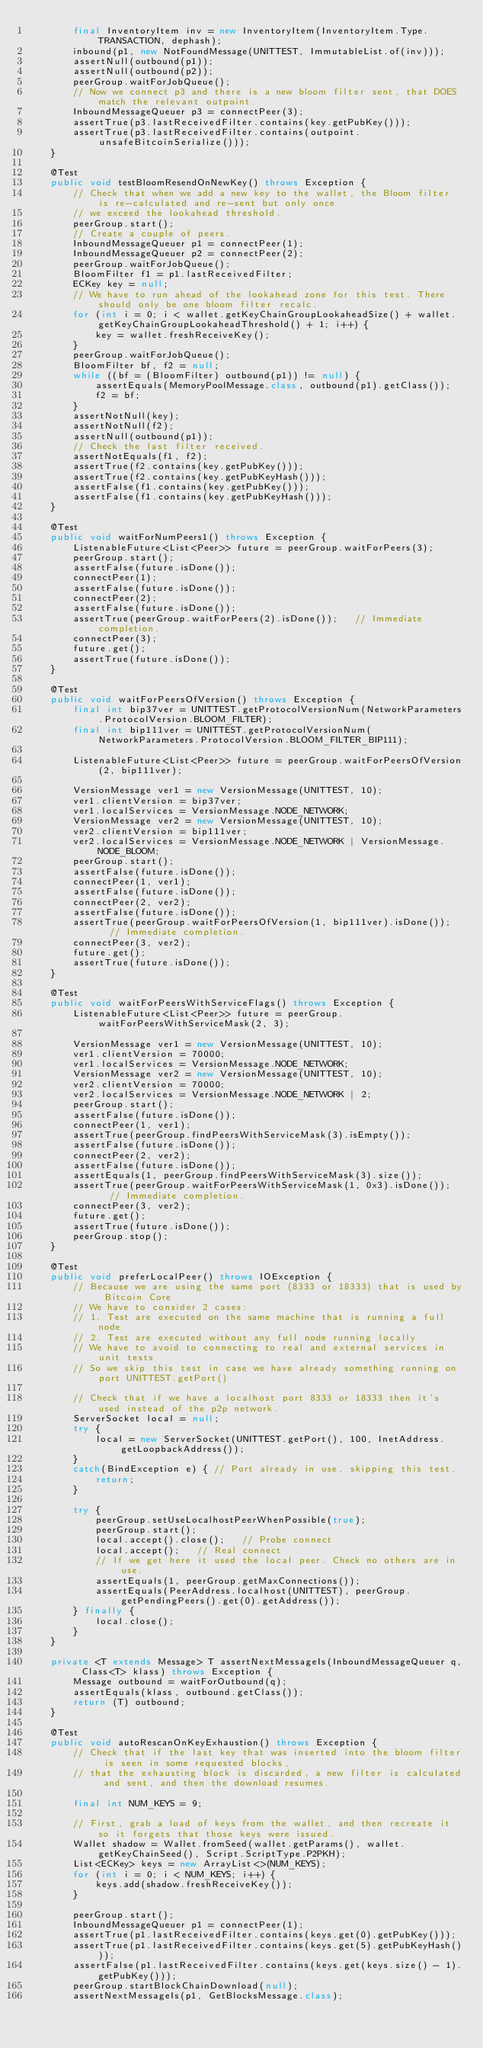Convert code to text. <code><loc_0><loc_0><loc_500><loc_500><_Java_>        final InventoryItem inv = new InventoryItem(InventoryItem.Type.TRANSACTION, dephash);
        inbound(p1, new NotFoundMessage(UNITTEST, ImmutableList.of(inv)));
        assertNull(outbound(p1));
        assertNull(outbound(p2));
        peerGroup.waitForJobQueue();
        // Now we connect p3 and there is a new bloom filter sent, that DOES match the relevant outpoint.
        InboundMessageQueuer p3 = connectPeer(3);
        assertTrue(p3.lastReceivedFilter.contains(key.getPubKey()));
        assertTrue(p3.lastReceivedFilter.contains(outpoint.unsafeBitcoinSerialize()));
    }

    @Test
    public void testBloomResendOnNewKey() throws Exception {
        // Check that when we add a new key to the wallet, the Bloom filter is re-calculated and re-sent but only once
        // we exceed the lookahead threshold.
        peerGroup.start();
        // Create a couple of peers.
        InboundMessageQueuer p1 = connectPeer(1);
        InboundMessageQueuer p2 = connectPeer(2);
        peerGroup.waitForJobQueue();
        BloomFilter f1 = p1.lastReceivedFilter;
        ECKey key = null;
        // We have to run ahead of the lookahead zone for this test. There should only be one bloom filter recalc.
        for (int i = 0; i < wallet.getKeyChainGroupLookaheadSize() + wallet.getKeyChainGroupLookaheadThreshold() + 1; i++) {
            key = wallet.freshReceiveKey();
        }
        peerGroup.waitForJobQueue();
        BloomFilter bf, f2 = null;
        while ((bf = (BloomFilter) outbound(p1)) != null) {
            assertEquals(MemoryPoolMessage.class, outbound(p1).getClass());
            f2 = bf;
        }
        assertNotNull(key);
        assertNotNull(f2);
        assertNull(outbound(p1));
        // Check the last filter received.
        assertNotEquals(f1, f2);
        assertTrue(f2.contains(key.getPubKey()));
        assertTrue(f2.contains(key.getPubKeyHash()));
        assertFalse(f1.contains(key.getPubKey()));
        assertFalse(f1.contains(key.getPubKeyHash()));
    }

    @Test
    public void waitForNumPeers1() throws Exception {
        ListenableFuture<List<Peer>> future = peerGroup.waitForPeers(3);
        peerGroup.start();
        assertFalse(future.isDone());
        connectPeer(1);
        assertFalse(future.isDone());
        connectPeer(2);
        assertFalse(future.isDone());
        assertTrue(peerGroup.waitForPeers(2).isDone());   // Immediate completion.
        connectPeer(3);
        future.get();
        assertTrue(future.isDone());
    }

    @Test
    public void waitForPeersOfVersion() throws Exception {
        final int bip37ver = UNITTEST.getProtocolVersionNum(NetworkParameters.ProtocolVersion.BLOOM_FILTER);
        final int bip111ver = UNITTEST.getProtocolVersionNum(NetworkParameters.ProtocolVersion.BLOOM_FILTER_BIP111);

        ListenableFuture<List<Peer>> future = peerGroup.waitForPeersOfVersion(2, bip111ver);

        VersionMessage ver1 = new VersionMessage(UNITTEST, 10);
        ver1.clientVersion = bip37ver;
        ver1.localServices = VersionMessage.NODE_NETWORK;
        VersionMessage ver2 = new VersionMessage(UNITTEST, 10);
        ver2.clientVersion = bip111ver;
        ver2.localServices = VersionMessage.NODE_NETWORK | VersionMessage.NODE_BLOOM;
        peerGroup.start();
        assertFalse(future.isDone());
        connectPeer(1, ver1);
        assertFalse(future.isDone());
        connectPeer(2, ver2);
        assertFalse(future.isDone());
        assertTrue(peerGroup.waitForPeersOfVersion(1, bip111ver).isDone());   // Immediate completion.
        connectPeer(3, ver2);
        future.get();
        assertTrue(future.isDone());
    }

    @Test
    public void waitForPeersWithServiceFlags() throws Exception {
        ListenableFuture<List<Peer>> future = peerGroup.waitForPeersWithServiceMask(2, 3);

        VersionMessage ver1 = new VersionMessage(UNITTEST, 10);
        ver1.clientVersion = 70000;
        ver1.localServices = VersionMessage.NODE_NETWORK;
        VersionMessage ver2 = new VersionMessage(UNITTEST, 10);
        ver2.clientVersion = 70000;
        ver2.localServices = VersionMessage.NODE_NETWORK | 2;
        peerGroup.start();
        assertFalse(future.isDone());
        connectPeer(1, ver1);
        assertTrue(peerGroup.findPeersWithServiceMask(3).isEmpty());
        assertFalse(future.isDone());
        connectPeer(2, ver2);
        assertFalse(future.isDone());
        assertEquals(1, peerGroup.findPeersWithServiceMask(3).size());
        assertTrue(peerGroup.waitForPeersWithServiceMask(1, 0x3).isDone());   // Immediate completion.
        connectPeer(3, ver2);
        future.get();
        assertTrue(future.isDone());
        peerGroup.stop();
    }

    @Test
    public void preferLocalPeer() throws IOException {
        // Because we are using the same port (8333 or 18333) that is used by Bitcoin Core
        // We have to consider 2 cases:
        // 1. Test are executed on the same machine that is running a full node
        // 2. Test are executed without any full node running locally
        // We have to avoid to connecting to real and external services in unit tests
        // So we skip this test in case we have already something running on port UNITTEST.getPort()

        // Check that if we have a localhost port 8333 or 18333 then it's used instead of the p2p network.
        ServerSocket local = null;
        try {
            local = new ServerSocket(UNITTEST.getPort(), 100, InetAddress.getLoopbackAddress());
        }
        catch(BindException e) { // Port already in use, skipping this test.
            return;
        }

        try {
            peerGroup.setUseLocalhostPeerWhenPossible(true);
            peerGroup.start();
            local.accept().close();   // Probe connect
            local.accept();   // Real connect
            // If we get here it used the local peer. Check no others are in use.
            assertEquals(1, peerGroup.getMaxConnections());
            assertEquals(PeerAddress.localhost(UNITTEST), peerGroup.getPendingPeers().get(0).getAddress());
        } finally {
            local.close();
        }
    }

    private <T extends Message> T assertNextMessageIs(InboundMessageQueuer q, Class<T> klass) throws Exception {
        Message outbound = waitForOutbound(q);
        assertEquals(klass, outbound.getClass());
        return (T) outbound;
    }

    @Test
    public void autoRescanOnKeyExhaustion() throws Exception {
        // Check that if the last key that was inserted into the bloom filter is seen in some requested blocks,
        // that the exhausting block is discarded, a new filter is calculated and sent, and then the download resumes.

        final int NUM_KEYS = 9;

        // First, grab a load of keys from the wallet, and then recreate it so it forgets that those keys were issued.
        Wallet shadow = Wallet.fromSeed(wallet.getParams(), wallet.getKeyChainSeed(), Script.ScriptType.P2PKH);
        List<ECKey> keys = new ArrayList<>(NUM_KEYS);
        for (int i = 0; i < NUM_KEYS; i++) {
            keys.add(shadow.freshReceiveKey());
        }

        peerGroup.start();
        InboundMessageQueuer p1 = connectPeer(1);
        assertTrue(p1.lastReceivedFilter.contains(keys.get(0).getPubKey()));
        assertTrue(p1.lastReceivedFilter.contains(keys.get(5).getPubKeyHash()));
        assertFalse(p1.lastReceivedFilter.contains(keys.get(keys.size() - 1).getPubKey()));
        peerGroup.startBlockChainDownload(null);
        assertNextMessageIs(p1, GetBlocksMessage.class);
</code> 